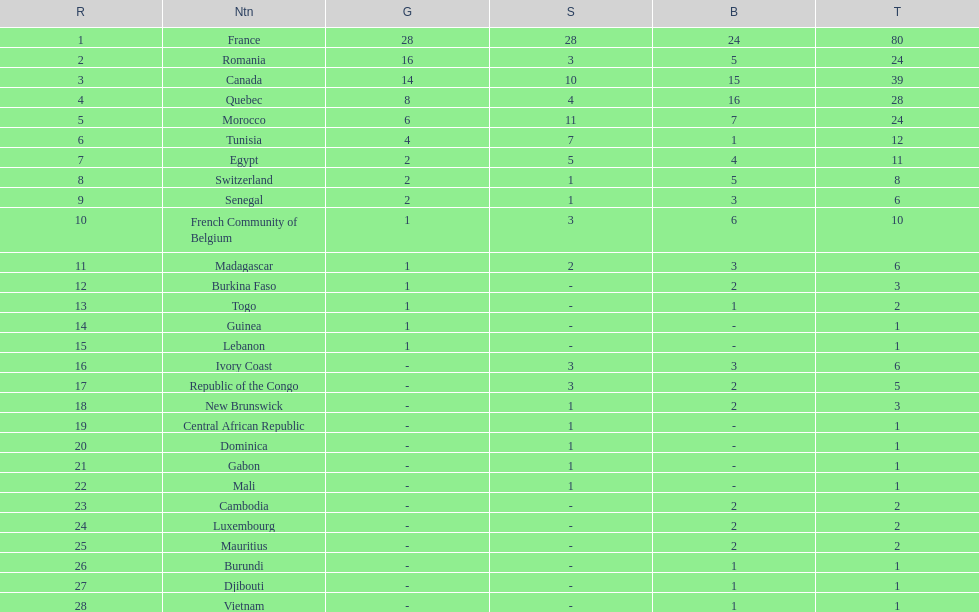How many counties have at least one silver medal? 18. Help me parse the entirety of this table. {'header': ['R', 'Ntn', 'G', 'S', 'B', 'T'], 'rows': [['1', 'France', '28', '28', '24', '80'], ['2', 'Romania', '16', '3', '5', '24'], ['3', 'Canada', '14', '10', '15', '39'], ['4', 'Quebec', '8', '4', '16', '28'], ['5', 'Morocco', '6', '11', '7', '24'], ['6', 'Tunisia', '4', '7', '1', '12'], ['7', 'Egypt', '2', '5', '4', '11'], ['8', 'Switzerland', '2', '1', '5', '8'], ['9', 'Senegal', '2', '1', '3', '6'], ['10', 'French Community of Belgium', '1', '3', '6', '10'], ['11', 'Madagascar', '1', '2', '3', '6'], ['12', 'Burkina Faso', '1', '-', '2', '3'], ['13', 'Togo', '1', '-', '1', '2'], ['14', 'Guinea', '1', '-', '-', '1'], ['15', 'Lebanon', '1', '-', '-', '1'], ['16', 'Ivory Coast', '-', '3', '3', '6'], ['17', 'Republic of the Congo', '-', '3', '2', '5'], ['18', 'New Brunswick', '-', '1', '2', '3'], ['19', 'Central African Republic', '-', '1', '-', '1'], ['20', 'Dominica', '-', '1', '-', '1'], ['21', 'Gabon', '-', '1', '-', '1'], ['22', 'Mali', '-', '1', '-', '1'], ['23', 'Cambodia', '-', '-', '2', '2'], ['24', 'Luxembourg', '-', '-', '2', '2'], ['25', 'Mauritius', '-', '-', '2', '2'], ['26', 'Burundi', '-', '-', '1', '1'], ['27', 'Djibouti', '-', '-', '1', '1'], ['28', 'Vietnam', '-', '-', '1', '1']]} 